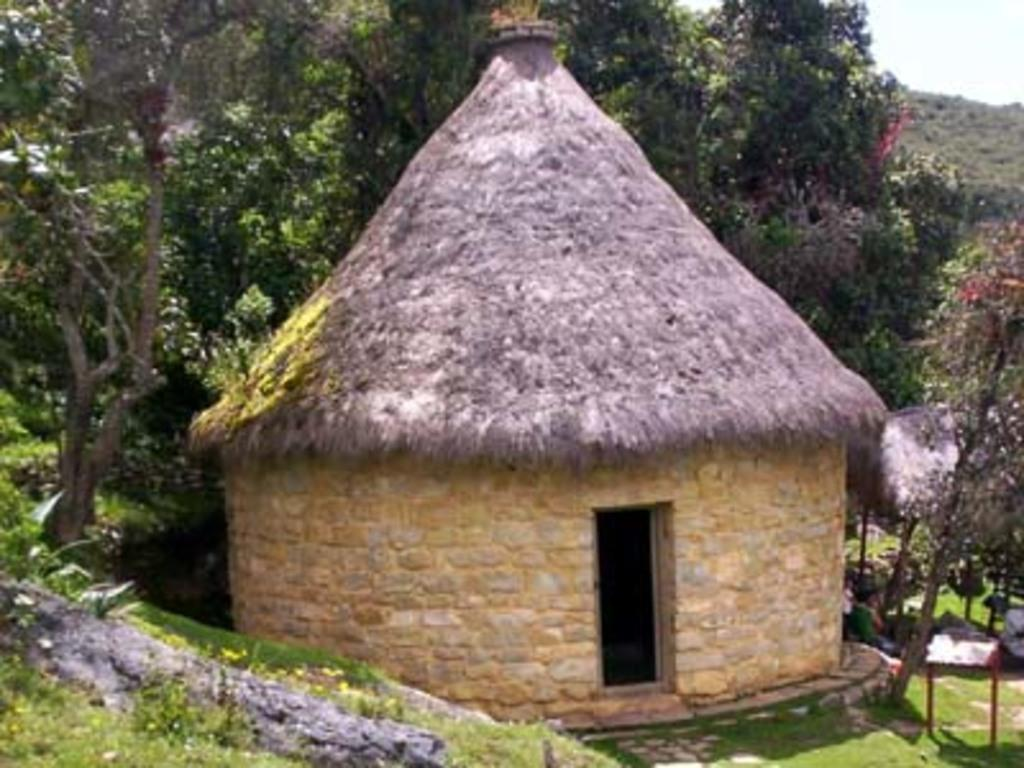What type of structure is in the picture? There is a hut in the picture. Who or what can be seen in the picture besides the hut? There are people in the picture. What can be seen in the background of the picture? There are trees and the sky visible in the background of the picture. What color is the nose of the person in the picture? There is no mention of a nose or a person's nose color in the provided facts, so it cannot be determined from the image. 